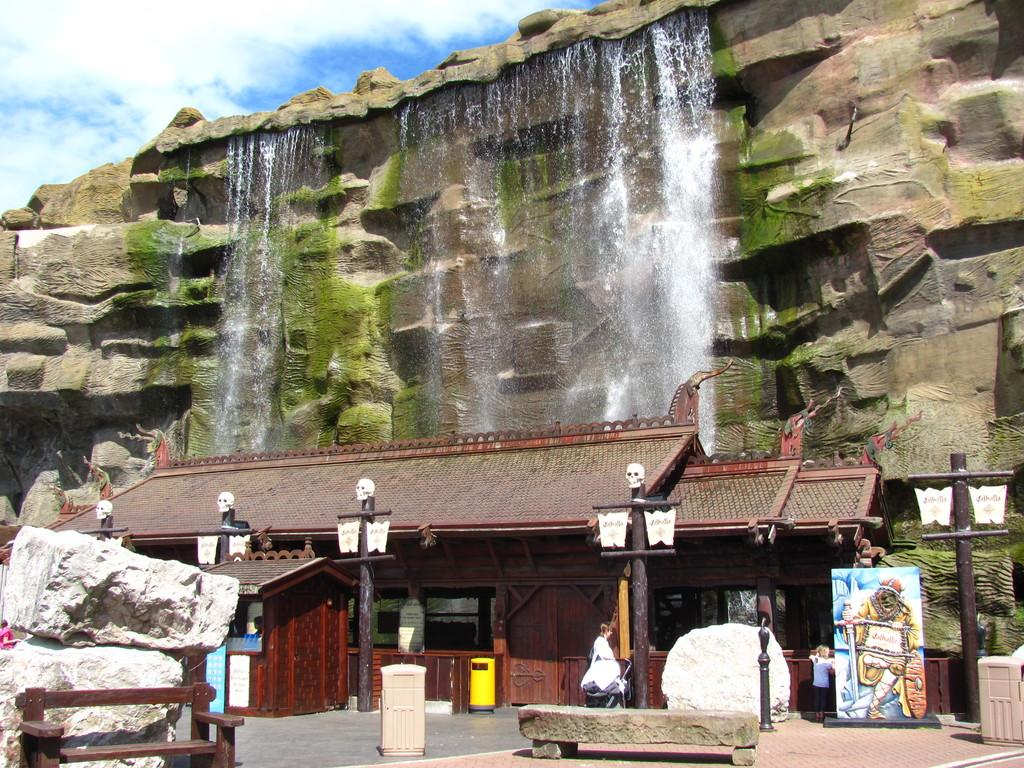What type of structure is visible in the image? There is a house in the image. What natural elements can be seen in the image? There are rocks and waterfalls in the image. What man-made objects are present in the image? There are poles, boards, bins, a hoarding, and a bench in the image. Are there any people in the image? Yes, there are people in the image. What can be seen in the background of the image? The sky is visible in the background of the image, with clouds present. What advice does the grandfather give to the people in the image? There is no grandfather present in the image, so no advice can be given. What type of acoustics can be heard in the image? The image is a still picture, so there is no sound or acoustics present. 